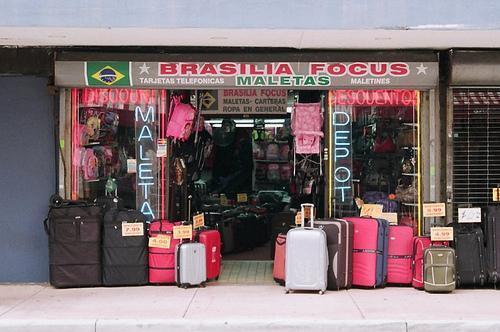How many stores are on the store's sign?
Give a very brief answer. 1. 